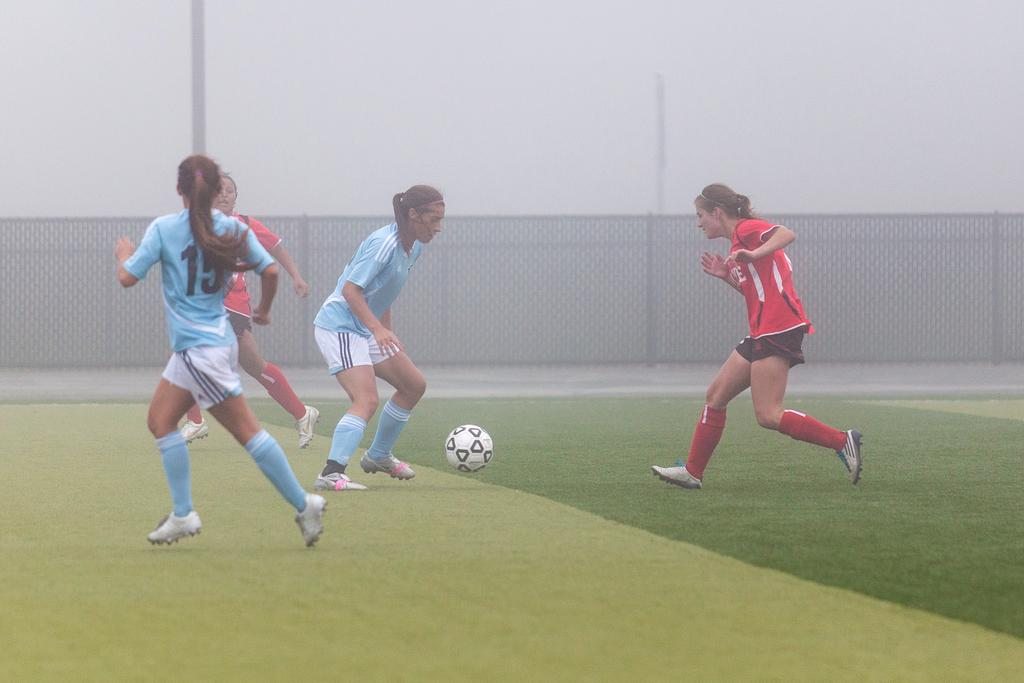Provide a one-sentence caption for the provided image. Player number 15 keeps an eye on the player with the ball as she runs. 